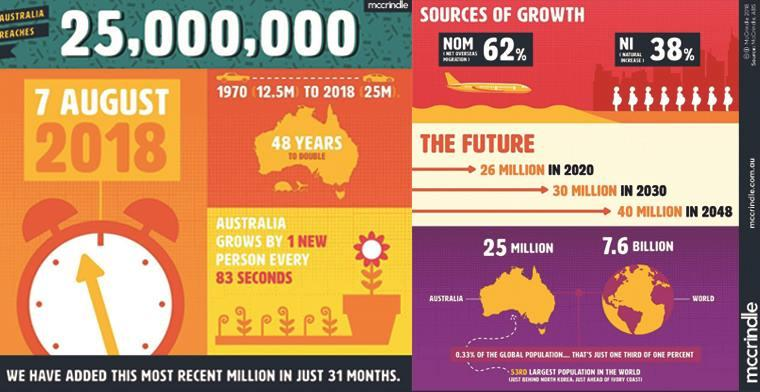List a handful of essential elements in this visual. In the year 2018, the world population was approximately 7.6 billion people. The population of Australia took 48 years to double from the year 1970. The population growth due to natural increase was 38%. 